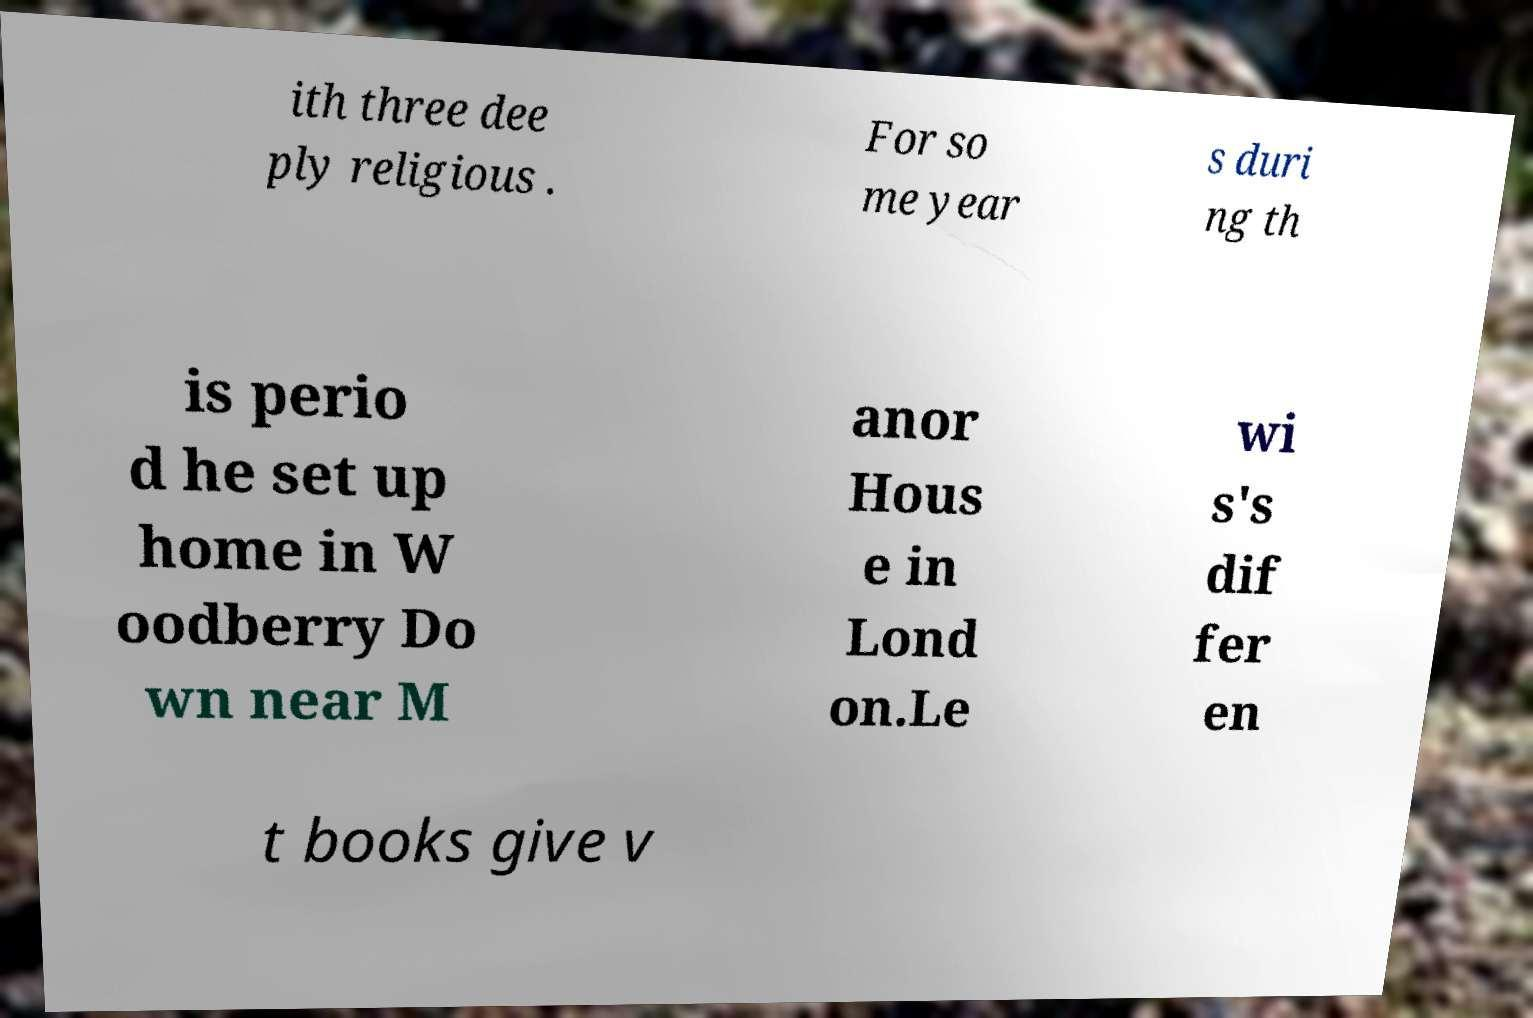There's text embedded in this image that I need extracted. Can you transcribe it verbatim? ith three dee ply religious . For so me year s duri ng th is perio d he set up home in W oodberry Do wn near M anor Hous e in Lond on.Le wi s's dif fer en t books give v 